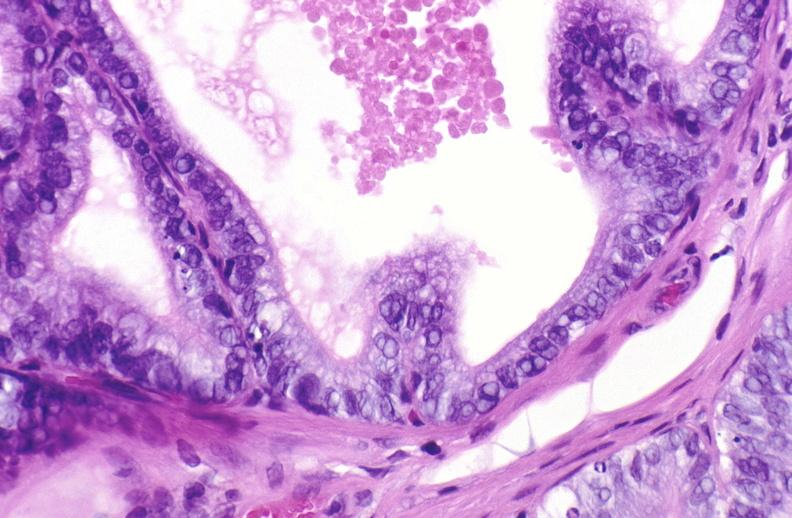when does this image show apoptosis in prostate?
Answer the question using a single word or phrase. After orchiectomy 